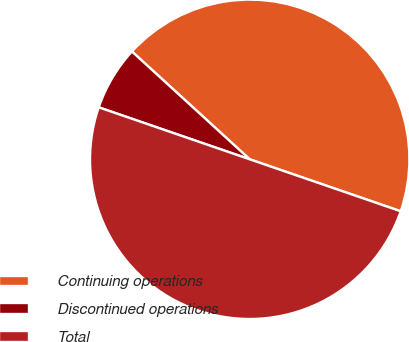Convert chart. <chart><loc_0><loc_0><loc_500><loc_500><pie_chart><fcel>Continuing operations<fcel>Discontinued operations<fcel>Total<nl><fcel>43.48%<fcel>6.52%<fcel>50.0%<nl></chart> 